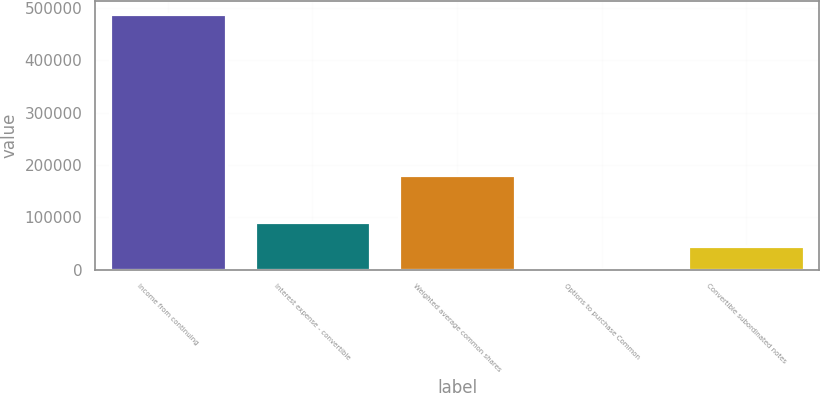<chart> <loc_0><loc_0><loc_500><loc_500><bar_chart><fcel>Income from continuing<fcel>Interest expense - convertible<fcel>Weighted average common shares<fcel>Options to purchase Common<fcel>Convertible subordinated notes<nl><fcel>488294<fcel>91234<fcel>181691<fcel>777<fcel>46005.5<nl></chart> 